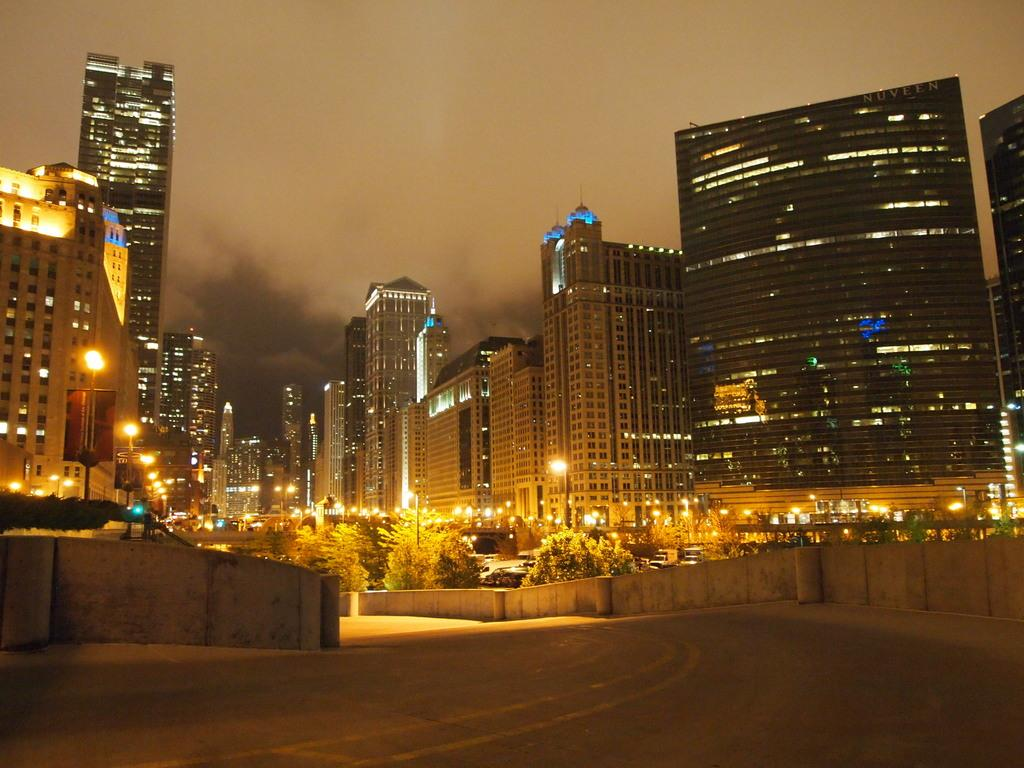What type of structures can be seen in the image? There are buildings in the image. What natural elements are present in the image? There are trees in the image. What type of transportation infrastructure is visible in the image? There are roads in the image. What object can be seen on a wall or surface in the image? There is a board in the image. What type of lighting is present in the image? There are street lights in the image. What type of disease is affecting the trees in the image? There is no indication of any disease affecting the trees in the image; they appear to be healthy. Can you see the moon in the image? The moon is not visible in the image; it only shows buildings, trees, roads, a board, and street lights. 